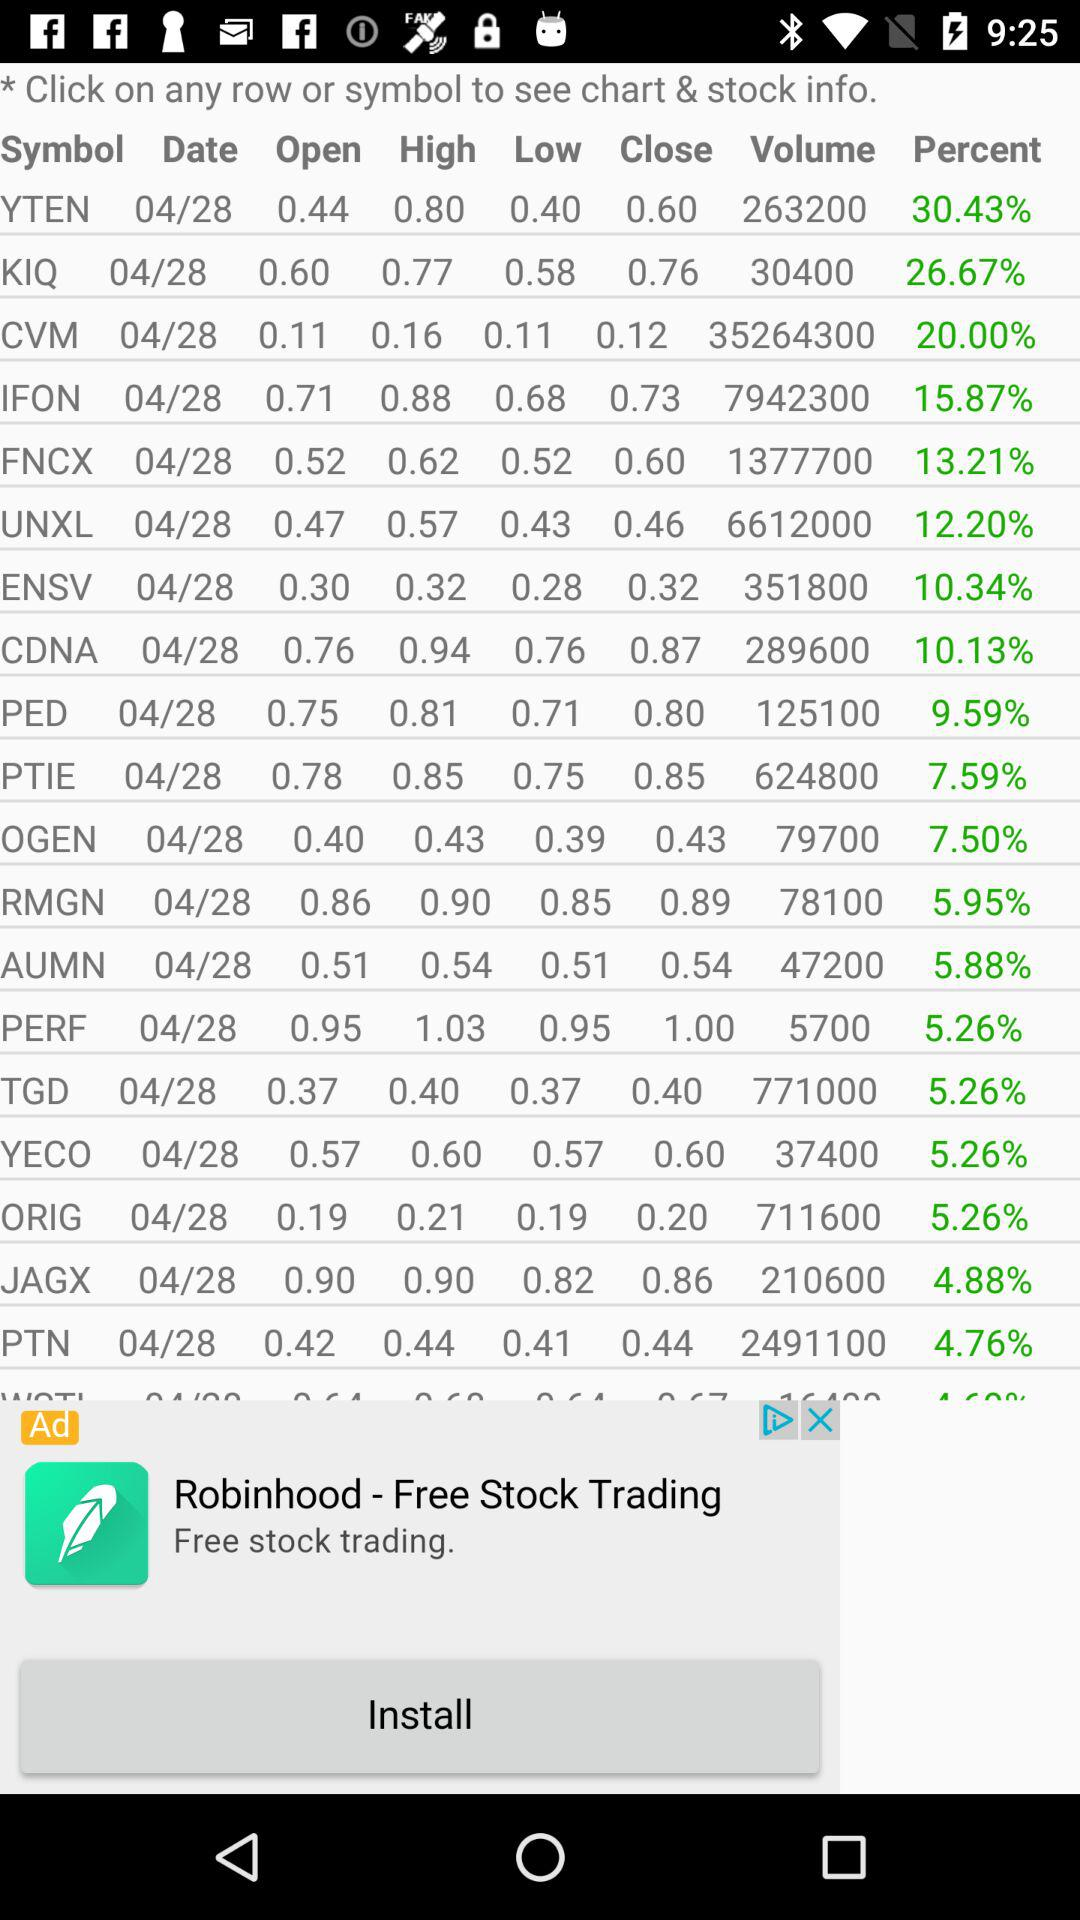What is the date?
When the provided information is insufficient, respond with <no answer>. <no answer> 